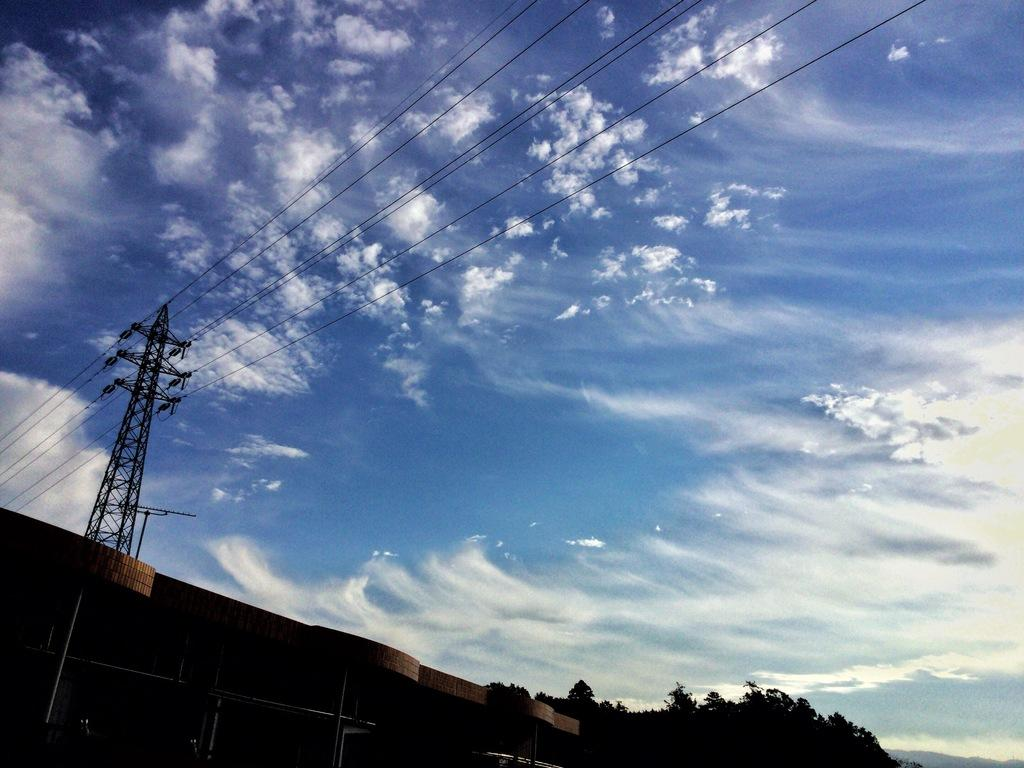What type of natural elements can be seen in the image? There are trees in the image. What man-made structures are present in the image? There is a building and a tower in the image. What else can be seen in the image besides trees and structures? There are wires in the image. What is visible in the sky in the image? The sky is visible in the image, and there are clouds in the sky. What type of glove is the judge wearing in the image? There is no judge or glove present in the image. What is the judge's neck doing in the image? There is no judge or neck present in the image. 